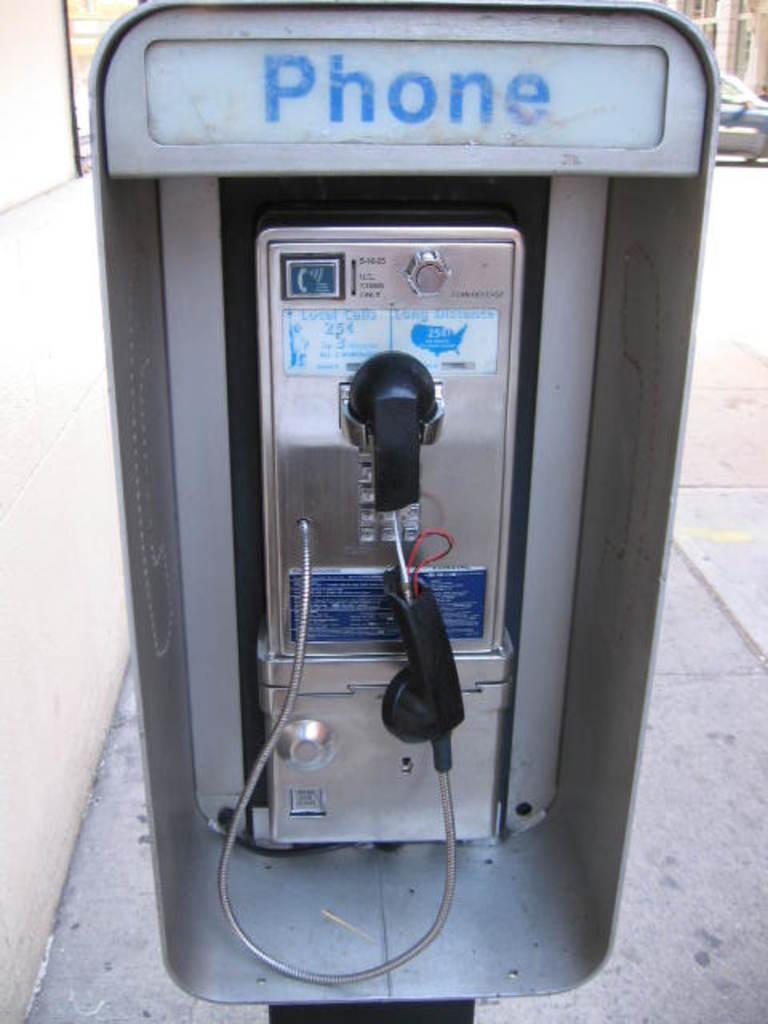How much is it to make a call?
Offer a very short reply. 25 cents. What does it say right above the pay phone?
Offer a terse response. Phone. 